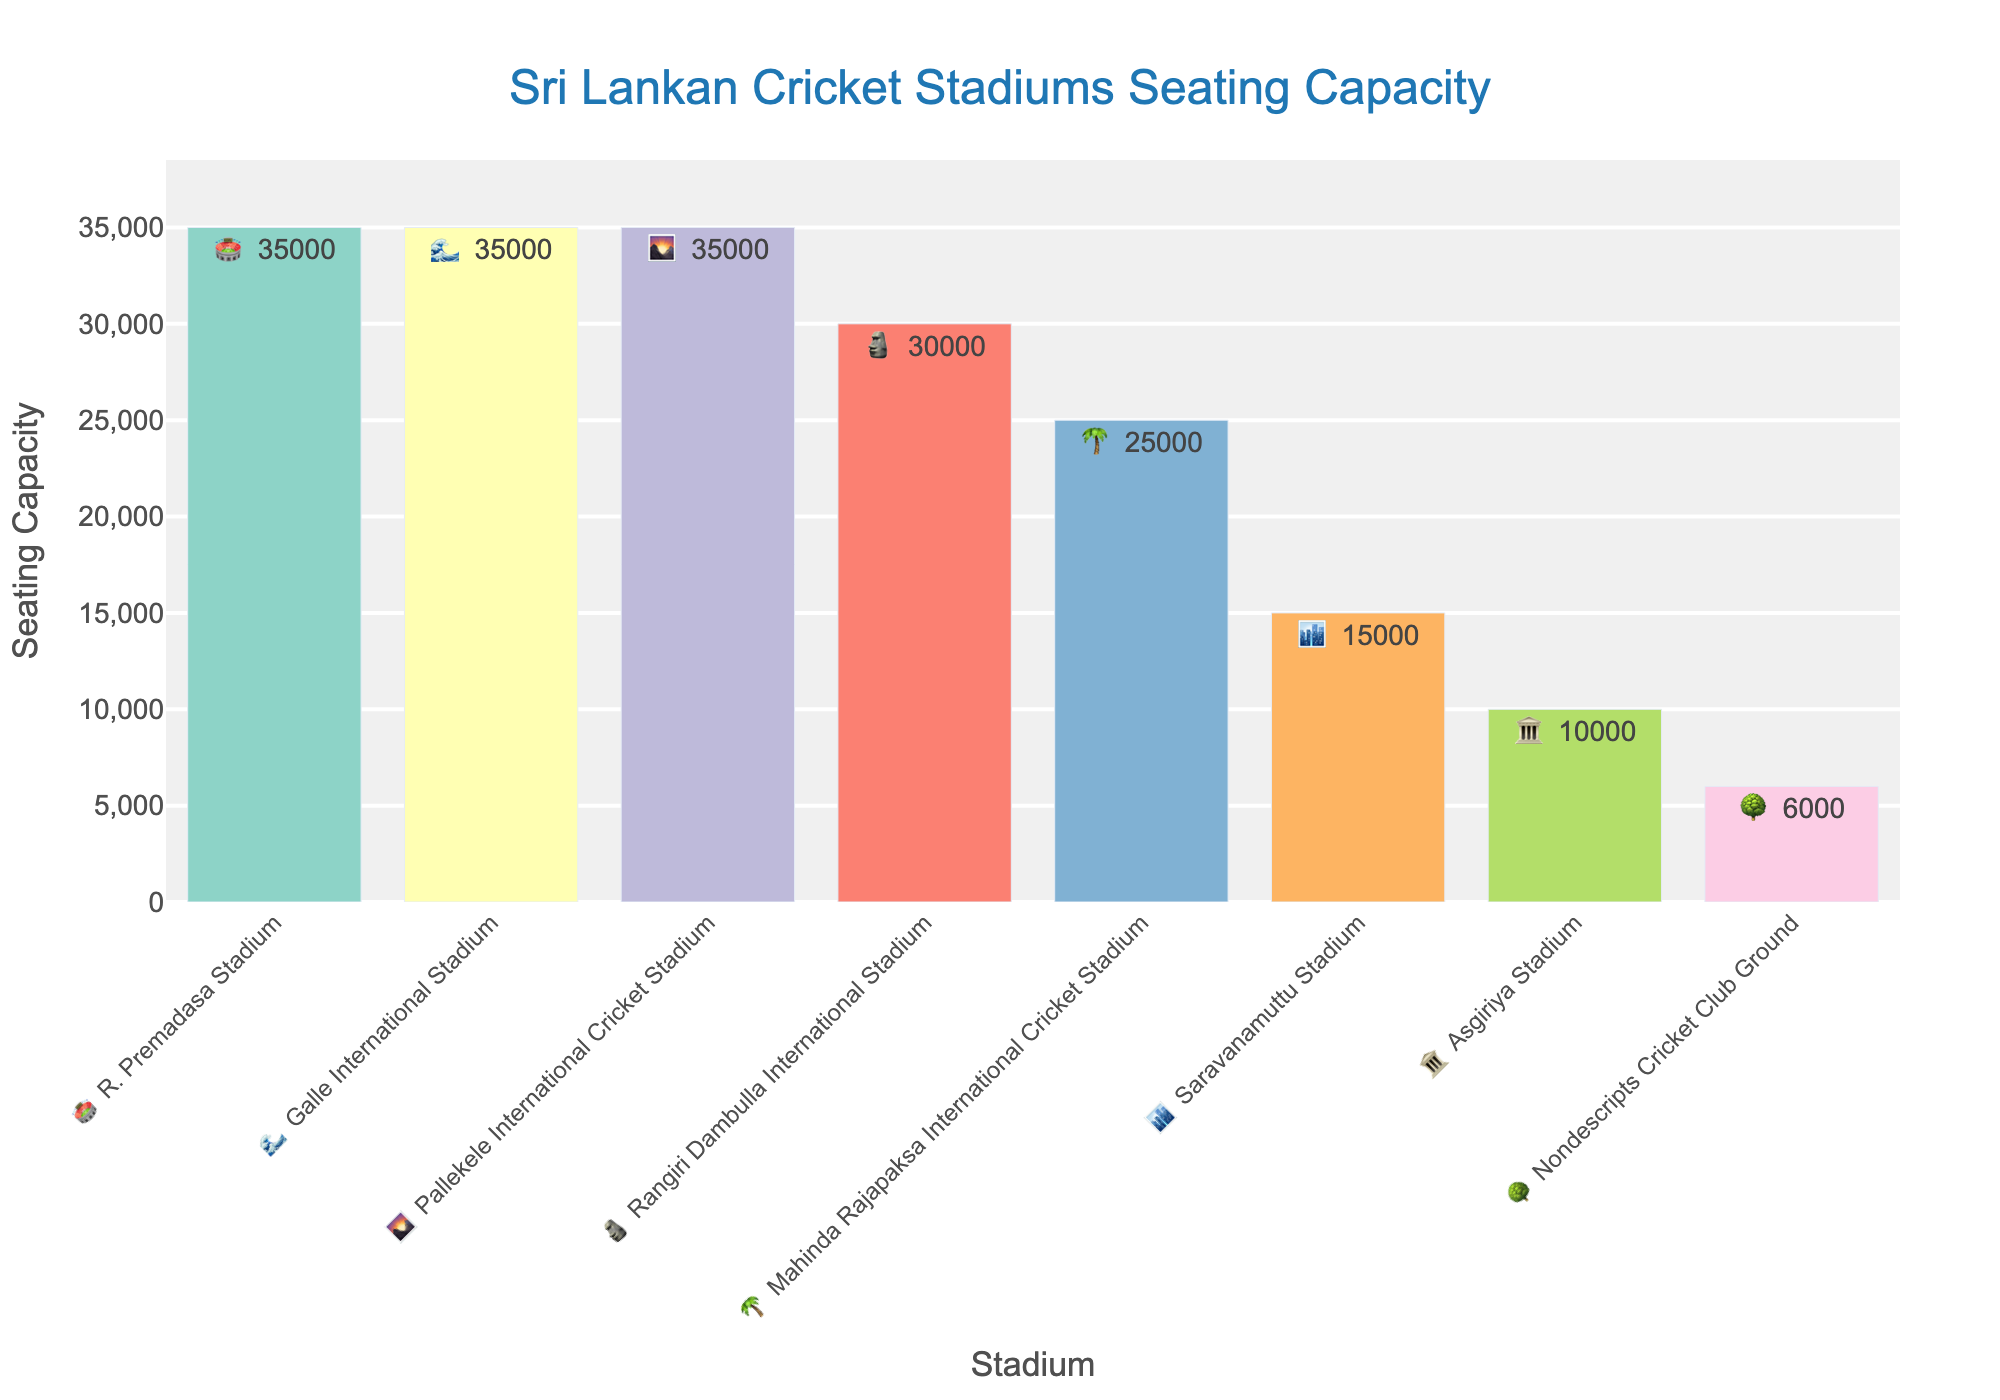What's the seating capacity at R. Premadasa Stadium? According to the figure, the capacity is listed next to each stadium's emoji. For R. Premadasa Stadium, the seating capacity is 35,000.
Answer: 35,000 Which stadium has the lowest seating capacity? The figure shows different seating capacities, the lowest one being 6,000 at the Nondescripts Cricket Club Ground.
Answer: Nondescripts Cricket Club Ground What's the total seating capacity of all the stadiums combined? Add the seating capacities: 35000 + 35000 + 35000 + 30000 + 25000 + 15000 + 10000 + 6000. The total seating capacity is 191,000.
Answer: 191,000 Which stadium has the same seating capacity as the Pallekele International Cricket Stadium? The figure shows that both Galle International Stadium and R. Premadasa Stadium share the same seating capacity as Pallekele International Cricket Stadium, which is 35,000.
Answer: Galle International Stadium and R. Premadasa Stadium What is the average seating capacity of all the stadiums? Add the seating capacities (191,000) and divide by the number of stadiums (8). The average seating capacity is 191,000 / 8 = 23,875.
Answer: 23,875 What is the difference in seating capacity between Rangiri Dambulla International Stadium and Mahinda Rajapaksa International Cricket Stadium? Subtract the seating capacity of Mahinda Rajapaksa International Cricket Stadium (25,000) from that of Rangiri Dambulla International Stadium (30,000). The difference is 30,000 - 25,000 = 5,000.
Answer: 5,000 List the stadiums in descending order of their seating capacity. The capacities in descending order are: 35,000 (R. Premadasa Stadium, Galle International Stadium, Pallekele International Cricket Stadium), 30,000 (Rangiri Dambulla International Stadium), 25,000 (Mahinda Rajapaksa International Cricket Stadium), 15,000 (Saravanamuttu Stadium), 10,000 (Asgiriya Stadium), 6,000 (Nondescripts Cricket Club Ground).
Answer: R. Premadasa Stadium, Galle International Stadium, Pallekele International Cricket Stadium, Rangiri Dambulla International Stadium, Mahinda Rajapaksa International Cricket Stadium, Saravanamuttu Stadium, Asgiriya Stadium, Nondescripts Cricket Club Ground How many stadiums have a seating capacity of 35,000? The figure shows that there are three stadiums each with a seating capacity of 35,000: R. Premadasa Stadium, Galle International Stadium, and Pallekele International Cricket Stadium.
Answer: 3 What's the emoji for the stadium with the second lowest seating capacity? The second lowest seating capacity is for Asgiriya Stadium with a capacity of 10,000. The emoji for Asgiriya Stadium is 🏛️.
Answer: 🏛️ 